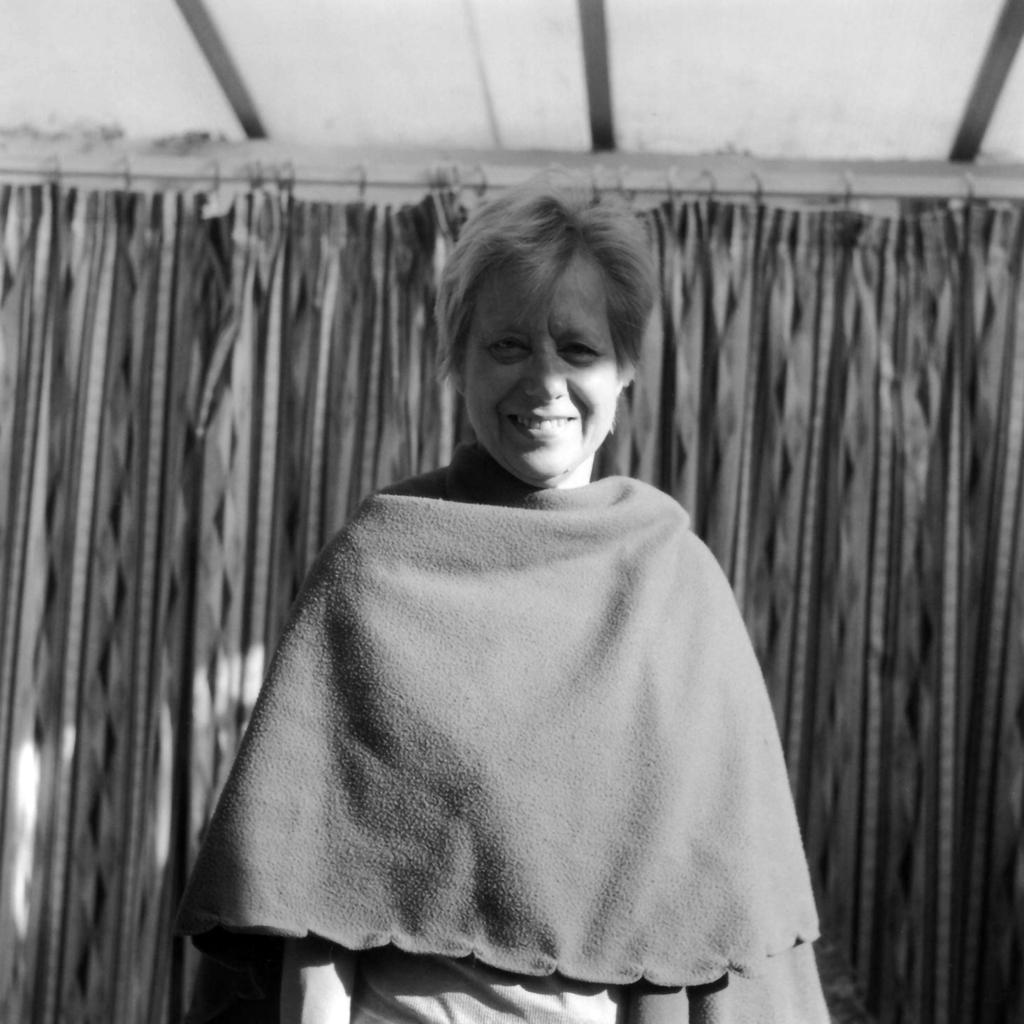Who is present in the image? There is a woman in the image. What is the woman's expression? The woman is smiling. What can be seen in the background of the image? There are curtains and some objects in the background of the image. How many dolls are sitting on the peace feather in the image? There are no dolls, peace feather, or any related objects present in the image. 